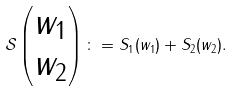<formula> <loc_0><loc_0><loc_500><loc_500>\mathcal { S } \begin{pmatrix} w _ { 1 } \\ w _ { 2 } \end{pmatrix} \colon = S _ { 1 } ( w _ { 1 } ) + S _ { 2 } ( w _ { 2 } ) .</formula> 